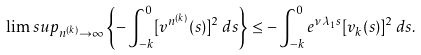Convert formula to latex. <formula><loc_0><loc_0><loc_500><loc_500>\lim s u p _ { n ^ { ( k ) } \rightarrow \infty } \left \{ - \int _ { - k } ^ { 0 } [ v ^ { n ^ { ( k ) } } ( s ) ] ^ { 2 } \, d s \right \} \leq - \int _ { - k } ^ { 0 } e ^ { \nu \lambda _ { 1 } s } [ v _ { k } ( s ) ] ^ { 2 } \, d s .</formula> 